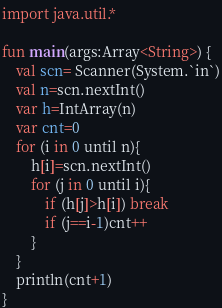<code> <loc_0><loc_0><loc_500><loc_500><_Kotlin_>import java.util.*

fun main(args:Array<String>) {
    val scn= Scanner(System.`in`)
    val n=scn.nextInt()
    var h=IntArray(n)
    var cnt=0
    for (i in 0 until n){
        h[i]=scn.nextInt()
        for (j in 0 until i){
            if (h[j]>h[i]) break
            if (j==i-1)cnt++
        }
    }
    println(cnt+1)
}
</code> 